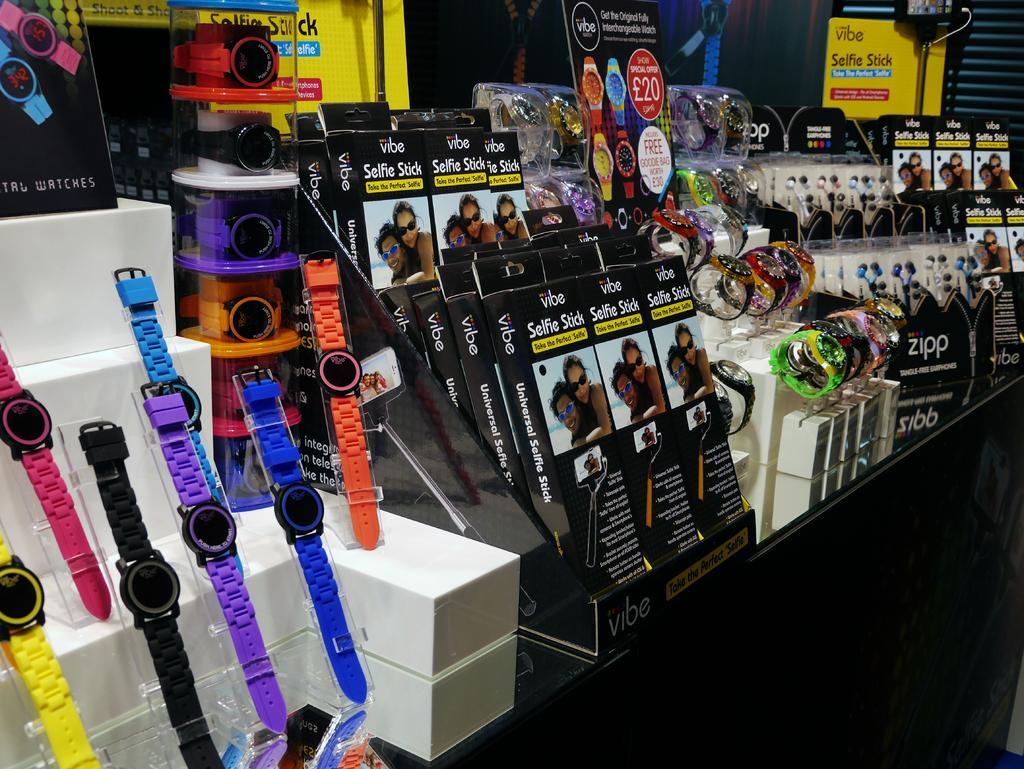Could you give a brief overview of what you see in this image? In this picture we can see watches,boxes and some objects. 